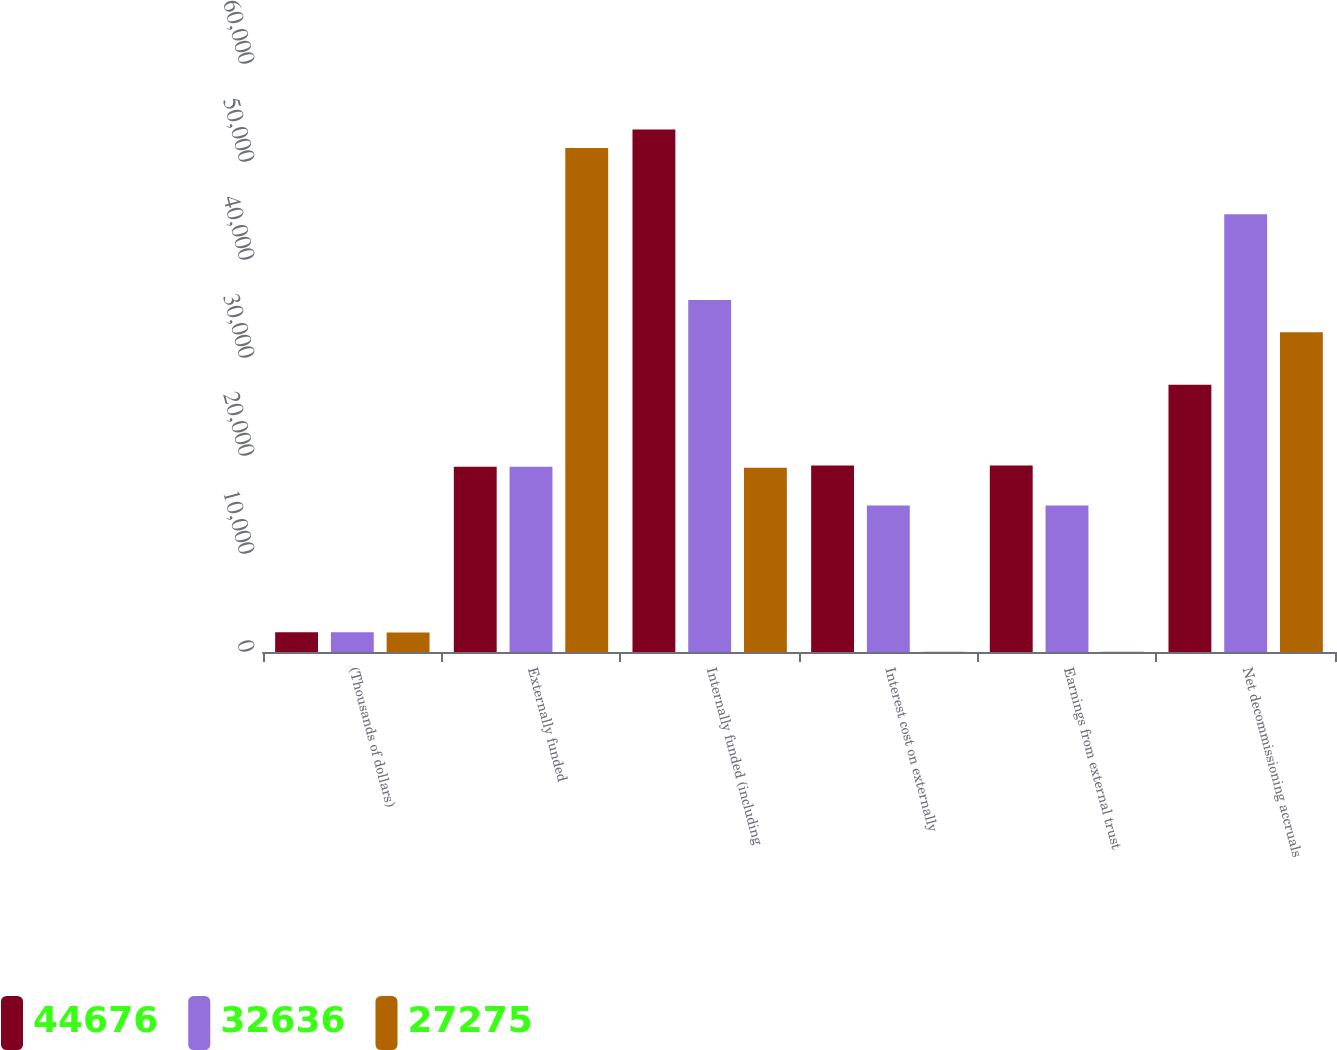Convert chart. <chart><loc_0><loc_0><loc_500><loc_500><stacked_bar_chart><ecel><fcel>(Thousands of dollars)<fcel>Externally funded<fcel>Internally funded (including<fcel>Interest cost on externally<fcel>Earnings from external trust<fcel>Net decommissioning accruals<nl><fcel>44676<fcel>2004<fcel>18911.5<fcel>53307<fcel>19026<fcel>19026<fcel>27275<nl><fcel>32636<fcel>2003<fcel>18911.5<fcel>35906<fcel>14952<fcel>14952<fcel>44676<nl><fcel>27275<fcel>2002<fcel>51433<fcel>18797<fcel>32<fcel>32<fcel>32636<nl></chart> 